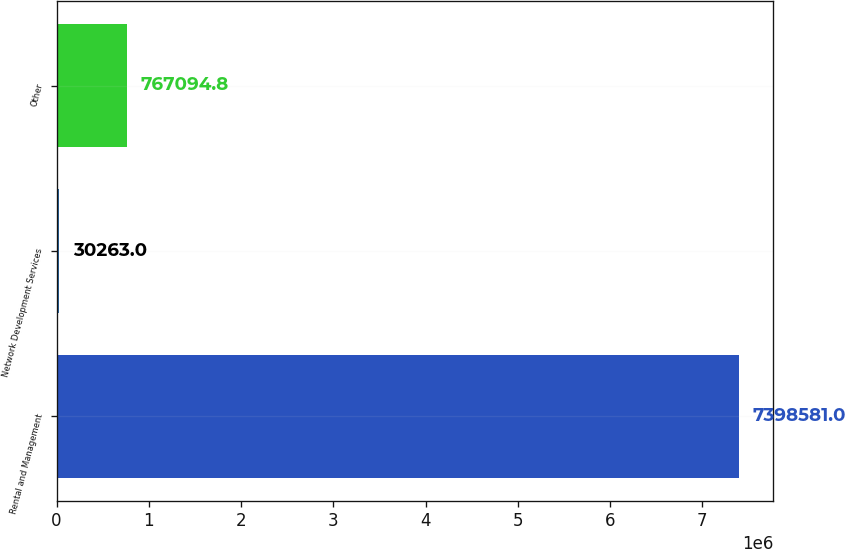Convert chart. <chart><loc_0><loc_0><loc_500><loc_500><bar_chart><fcel>Rental and Management<fcel>Network Development Services<fcel>Other<nl><fcel>7.39858e+06<fcel>30263<fcel>767095<nl></chart> 